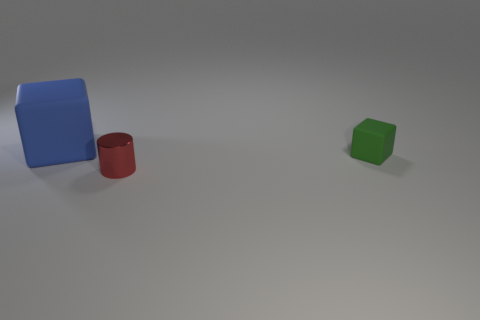Is there any other thing that has the same size as the blue rubber block?
Ensure brevity in your answer.  No. Are there any green objects of the same shape as the large blue object?
Your answer should be compact. Yes. What shape is the thing that is both left of the small green rubber object and behind the tiny red thing?
Make the answer very short. Cube. Is the large blue cube made of the same material as the small object that is behind the small red metal cylinder?
Offer a terse response. Yes. Are there any blocks behind the small green cube?
Your answer should be compact. Yes. What number of objects are either big red things or tiny things behind the red thing?
Your answer should be very brief. 1. What color is the tiny object that is to the left of the tiny thing behind the red shiny cylinder?
Give a very brief answer. Red. What number of other things are there of the same material as the green cube
Offer a very short reply. 1. How many rubber things are big blue things or large green spheres?
Make the answer very short. 1. There is another rubber thing that is the same shape as the green thing; what is its color?
Your answer should be compact. Blue. 